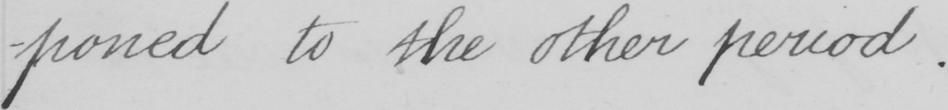What text is written in this handwritten line? -poned to the other period . 